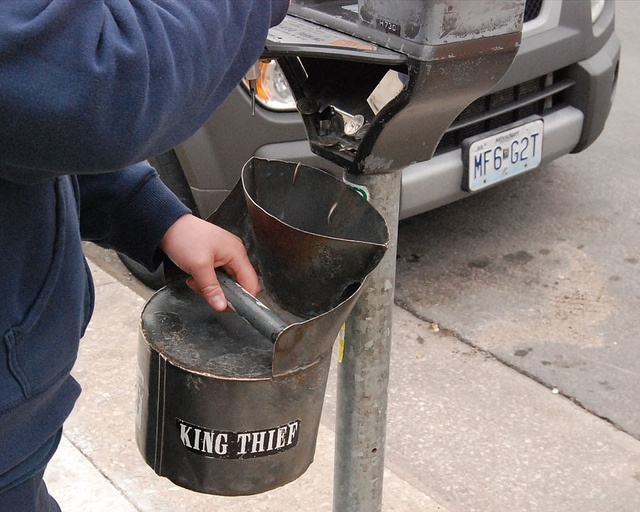Describe the objects in this image and their specific colors. I can see people in gray, black, and darkblue tones, car in darkblue, gray, darkgray, black, and lightgray tones, and parking meter in darkblue, gray, black, and darkgray tones in this image. 